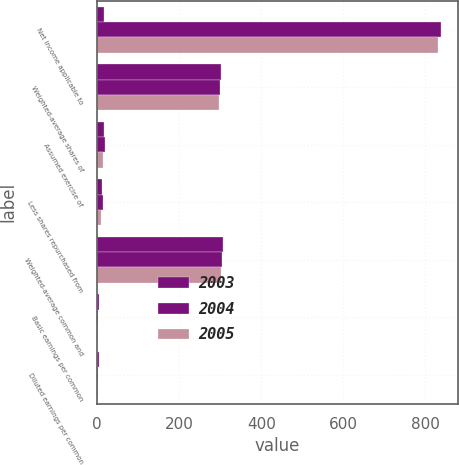Convert chart. <chart><loc_0><loc_0><loc_500><loc_500><stacked_bar_chart><ecel><fcel>Net income applicable to<fcel>Weighted-average shares of<fcel>Assumed exercise of<fcel>Less shares repurchased from<fcel>Weighted-average common and<fcel>Basic earnings per common<fcel>Diluted earnings per common<nl><fcel>2003<fcel>16.5<fcel>301<fcel>18<fcel>12<fcel>307<fcel>4.81<fcel>4.72<nl><fcel>2004<fcel>838<fcel>299<fcel>19<fcel>14<fcel>304<fcel>2.8<fcel>2.76<nl><fcel>2005<fcel>830<fcel>298<fcel>15<fcel>10<fcel>303<fcel>2.79<fcel>2.74<nl></chart> 